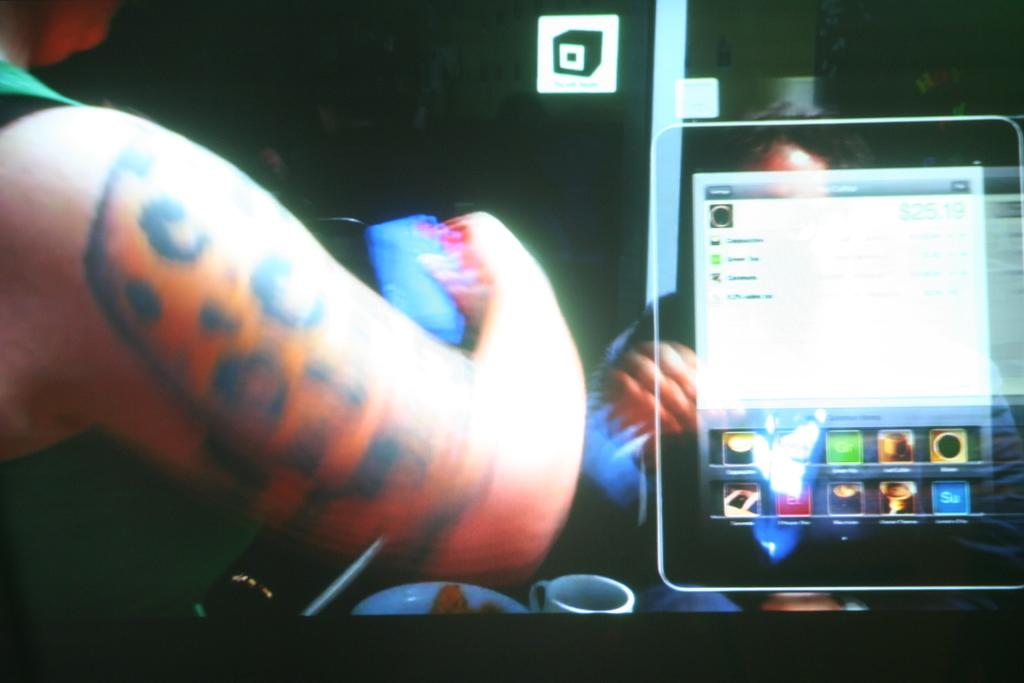Who or what is on the left side of the image? There is a person on the left side of the image. What can be seen in the middle of the image? There is a screen in the image. Who or what is on the right side of the image? There is a person beside the screen on the right side. How would you describe the background of the image? The background of the image is dark in color. How much butter is being measured by the person on the right side of the image? There is no butter or measuring activity present in the image. What type of beetle can be seen crawling on the screen in the image? There are no beetles present in the image; the screen is the only object visible in the middle of the image. 